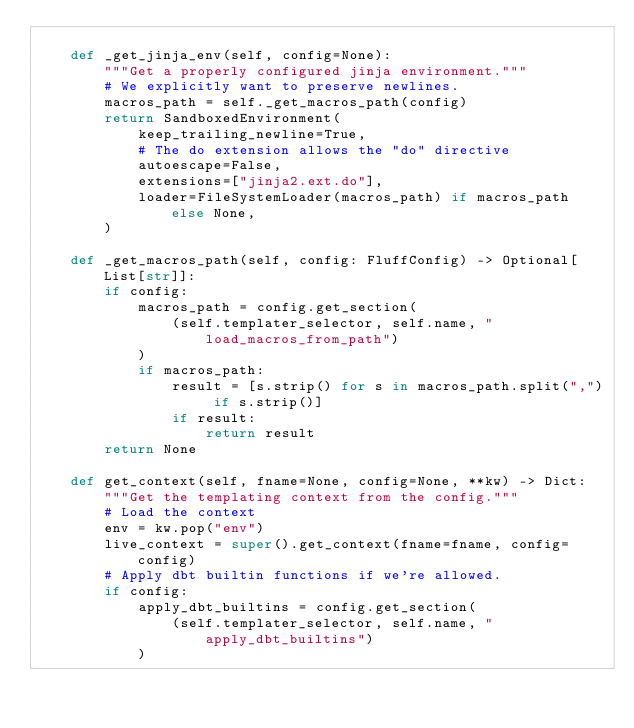<code> <loc_0><loc_0><loc_500><loc_500><_Python_>
    def _get_jinja_env(self, config=None):
        """Get a properly configured jinja environment."""
        # We explicitly want to preserve newlines.
        macros_path = self._get_macros_path(config)
        return SandboxedEnvironment(
            keep_trailing_newline=True,
            # The do extension allows the "do" directive
            autoescape=False,
            extensions=["jinja2.ext.do"],
            loader=FileSystemLoader(macros_path) if macros_path else None,
        )

    def _get_macros_path(self, config: FluffConfig) -> Optional[List[str]]:
        if config:
            macros_path = config.get_section(
                (self.templater_selector, self.name, "load_macros_from_path")
            )
            if macros_path:
                result = [s.strip() for s in macros_path.split(",") if s.strip()]
                if result:
                    return result
        return None

    def get_context(self, fname=None, config=None, **kw) -> Dict:
        """Get the templating context from the config."""
        # Load the context
        env = kw.pop("env")
        live_context = super().get_context(fname=fname, config=config)
        # Apply dbt builtin functions if we're allowed.
        if config:
            apply_dbt_builtins = config.get_section(
                (self.templater_selector, self.name, "apply_dbt_builtins")
            )</code> 